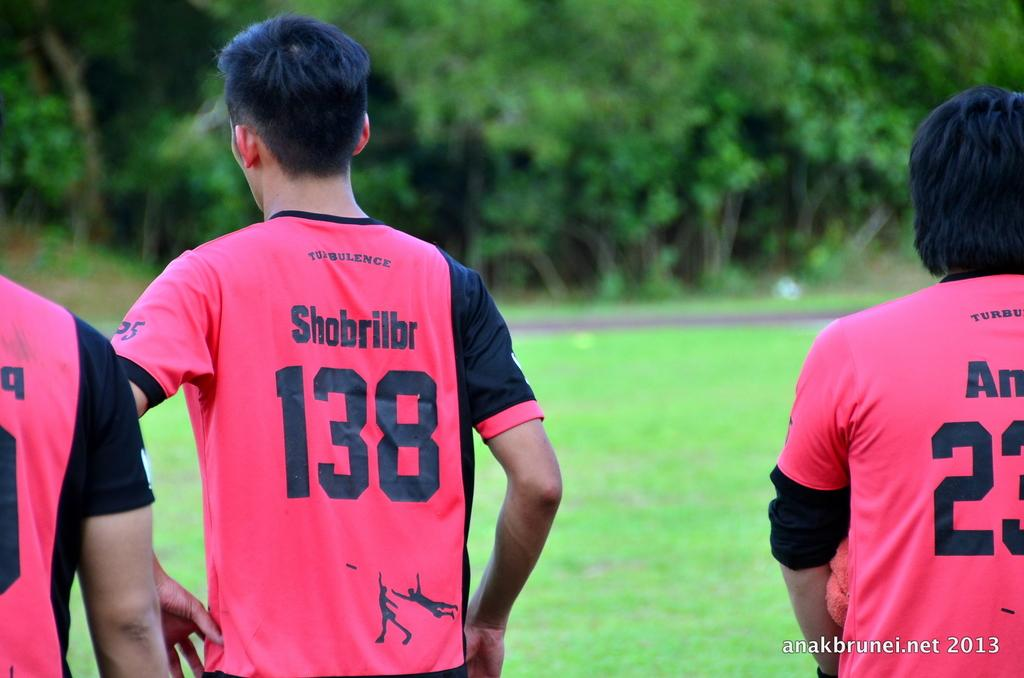<image>
Relay a brief, clear account of the picture shown. Boy wearing a red and black jersey with the number 138. 